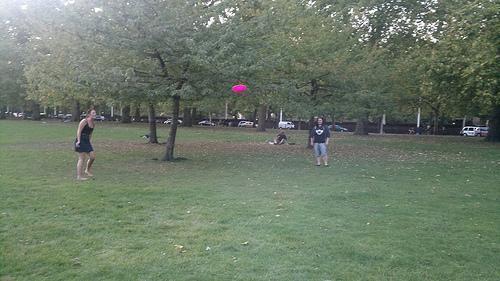How many people?
Give a very brief answer. 3. 